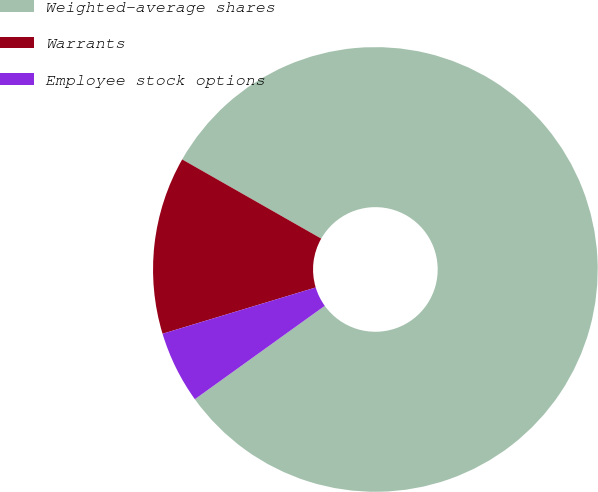<chart> <loc_0><loc_0><loc_500><loc_500><pie_chart><fcel>Weighted-average shares<fcel>Warrants<fcel>Employee stock options<nl><fcel>81.84%<fcel>12.91%<fcel>5.25%<nl></chart> 